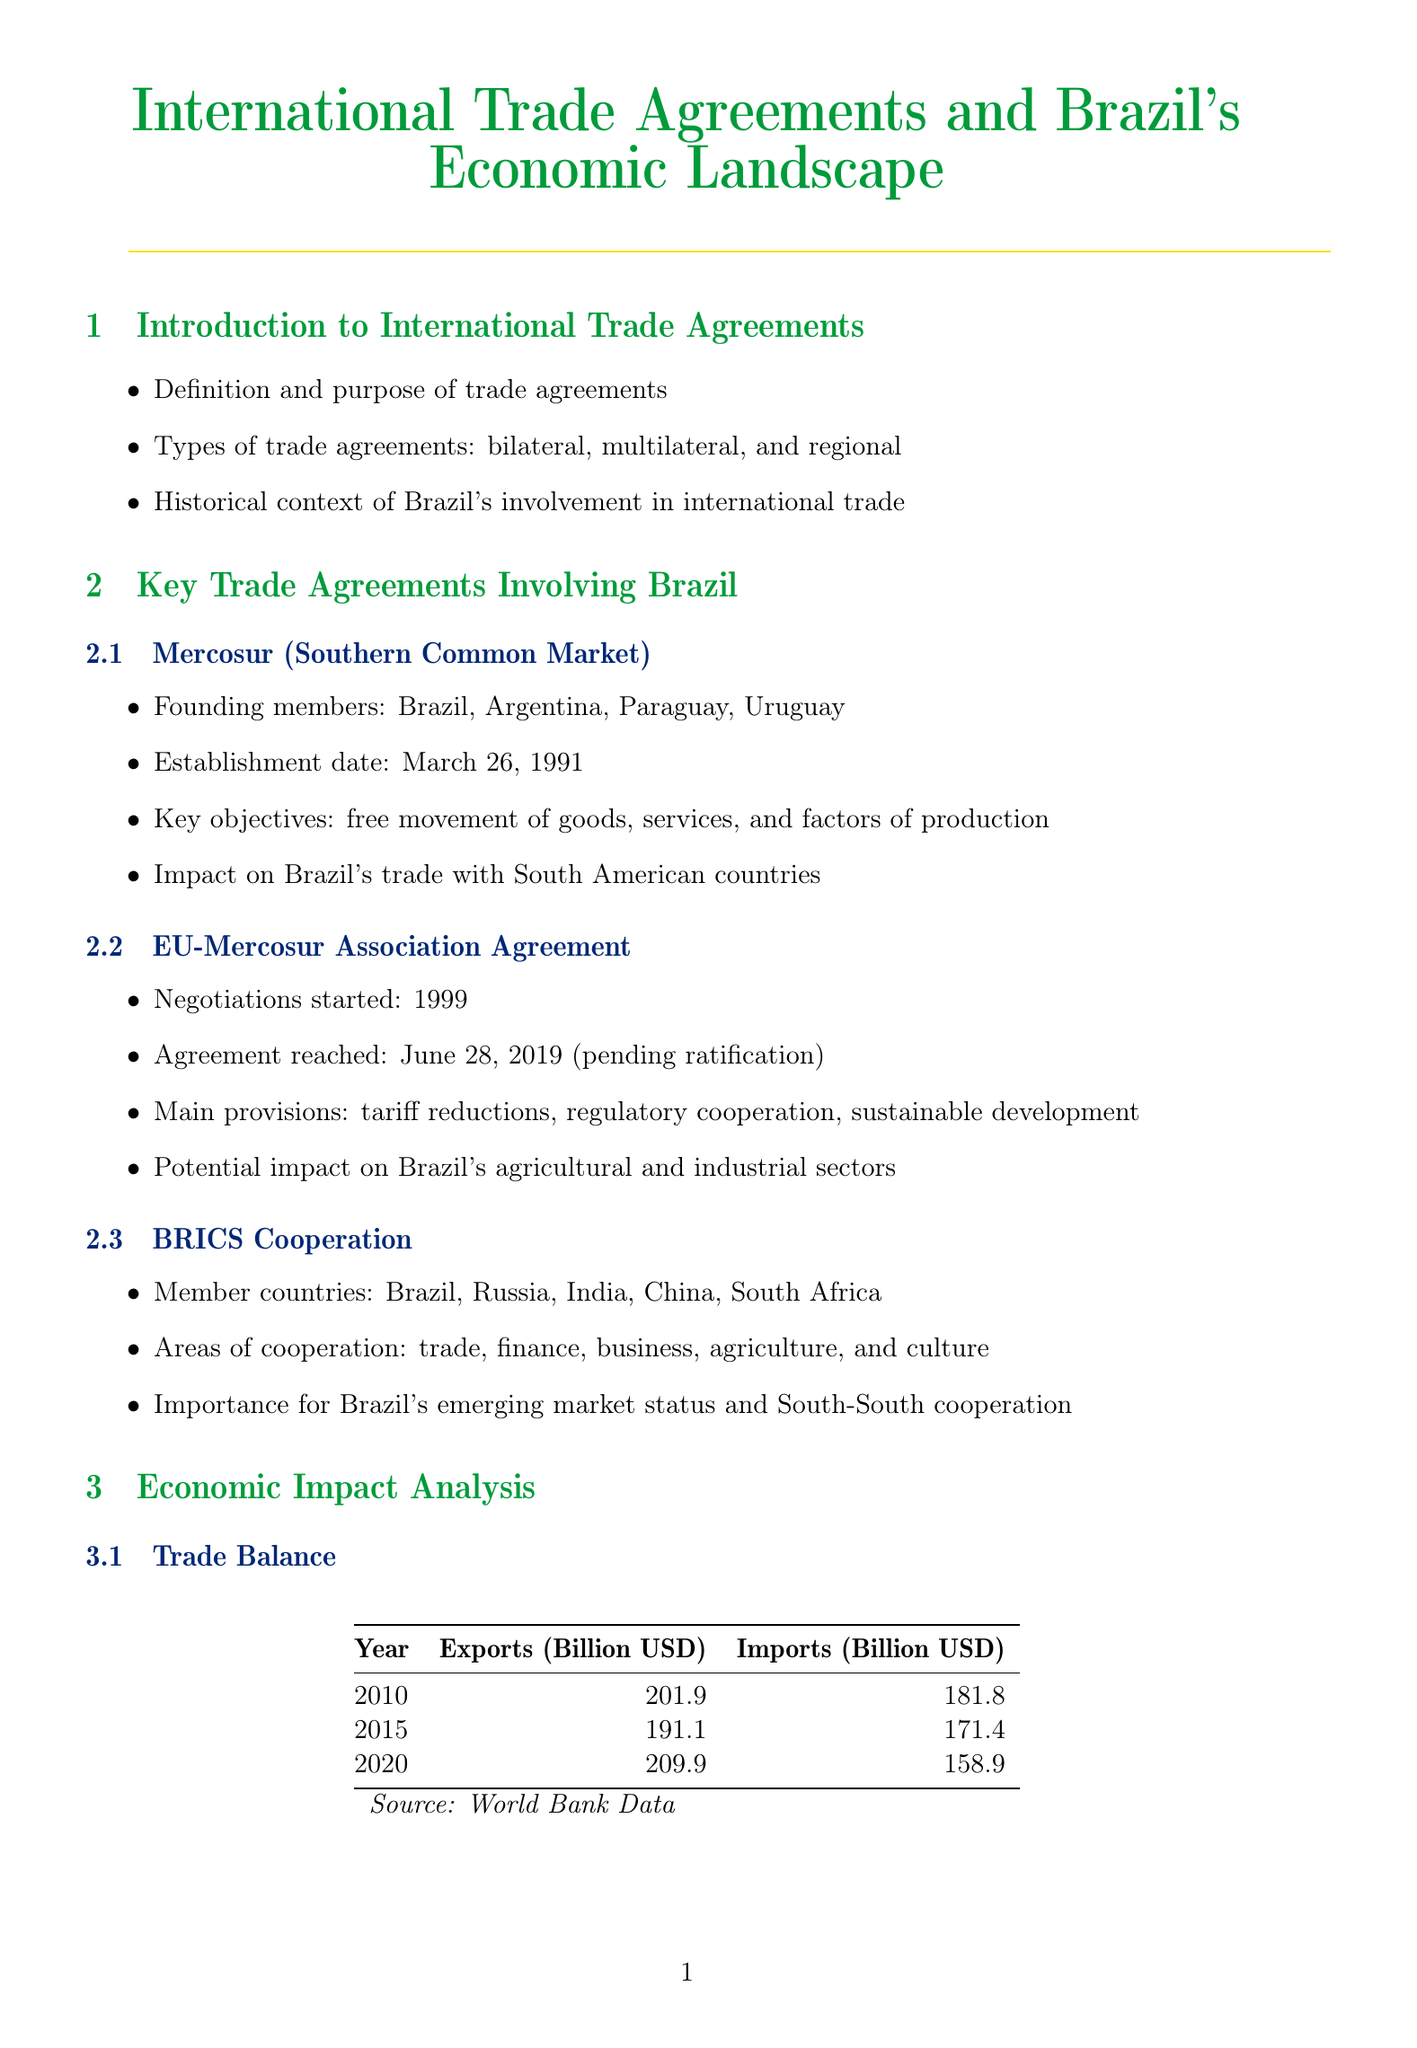What is the title of the manual? The title of the manual is provided at the beginning and serves as the main focus of the document.
Answer: International Trade Agreements and Brazil's Economic Landscape When was Mercosur established? The establishment date of Mercosur is included in the section discussing key trade agreements.
Answer: March 26, 1991 What is the proposed deal value of the Embraer-Boeing strategic partnership? This deal value is mentioned in the case study of the partnership, illustrating a significant international collaboration.
Answer: $4.2 billion What was the FDI inflow to Brazil in 2010? The document contains a table with data on Foreign Direct Investment, specifying figures for different years.
Answer: 88.5 billion USD What is a key objective of the EU-Mercosur Association Agreement? The objectives of this agreement are highlighted in the section on key trade agreements to indicate its purpose.
Answer: Tariff reductions What challenges are noted for Vale's iron ore exports? The content discussing Vale identifies specific issues related to its export operations amidst international trade dynamics.
Answer: Price volatility Which sectors are highlighted in the sectoral impact analysis? The manual lists various sectors that have been impacted by trade agreements, showing the broader economic effects.
Answer: Agriculture, Manufacturing, Services What recommendation is given for enhancing Brazil's position in global value chains? The future prospects section outlines a recommendation to improve Brazil's competitiveness in international trade.
Answer: Strengthening Brazil's position in global value chains 